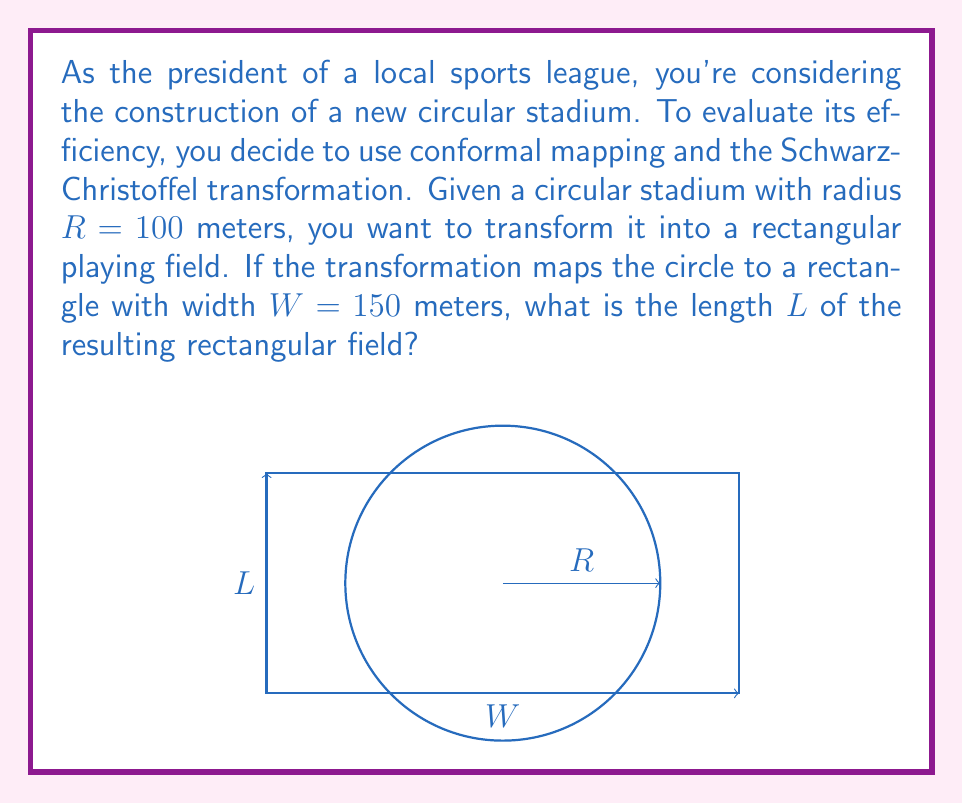Solve this math problem. To solve this problem, we'll use the properties of conformal mapping and the Schwarz-Christoffel transformation. Here's a step-by-step approach:

1) The Schwarz-Christoffel transformation maps the upper half-plane to a polygon. In our case, we first need to map the circle to the upper half-plane using the Möbius transformation:

   $$ f(z) = \frac{z - i}{z + i} $$

2) Then, we use the Schwarz-Christoffel transformation to map the upper half-plane to a rectangle. The general form of this transformation is:

   $$ g(w) = A \int_0^w \frac{d\zeta}{\sqrt{(1-\zeta^2)(1-k^2\zeta^2)}} + B $$

   where $k$ is the modulus of the elliptic integral.

3) The composition of these two transformations maps our circle to a rectangle. The modulus $k$ is related to the aspect ratio of the rectangle:

   $$ \frac{K(k')}{K(k)} = \frac{L}{W} $$

   where $K(k)$ is the complete elliptic integral of the first kind, and $k' = \sqrt{1-k^2}$.

4) For a circle of radius $R$, the area is $\pi R^2$. The area of the rectangle is $WL$. Since conformal mappings preserve local angles but not necessarily areas, we need to account for a scaling factor. Let's call this factor $s$. Then:

   $$ s\pi R^2 = WL $$

5) From the given information, $R = 100$ and $W = 150$. Substituting these into the area equation:

   $$ L = \frac{s\pi R^2}{W} = \frac{s\pi (100)^2}{150} = \frac{200s\pi}{3} $$

6) The exact value of $s$ depends on the specific Schwarz-Christoffel transformation used. In practice, $s$ is often close to 1, but can vary. Without more information about the specific transformation, we can't determine the exact value of $L$.

7) However, if we assume $s \approx 1$ for a rough estimate, we get:

   $$ L \approx \frac{200\pi}{3} \approx 209.44 \text{ meters} $$

This is an approximation and the actual value may differ based on the specific transformation used.
Answer: $L \approx 209.44$ meters (assuming a scaling factor of 1) 